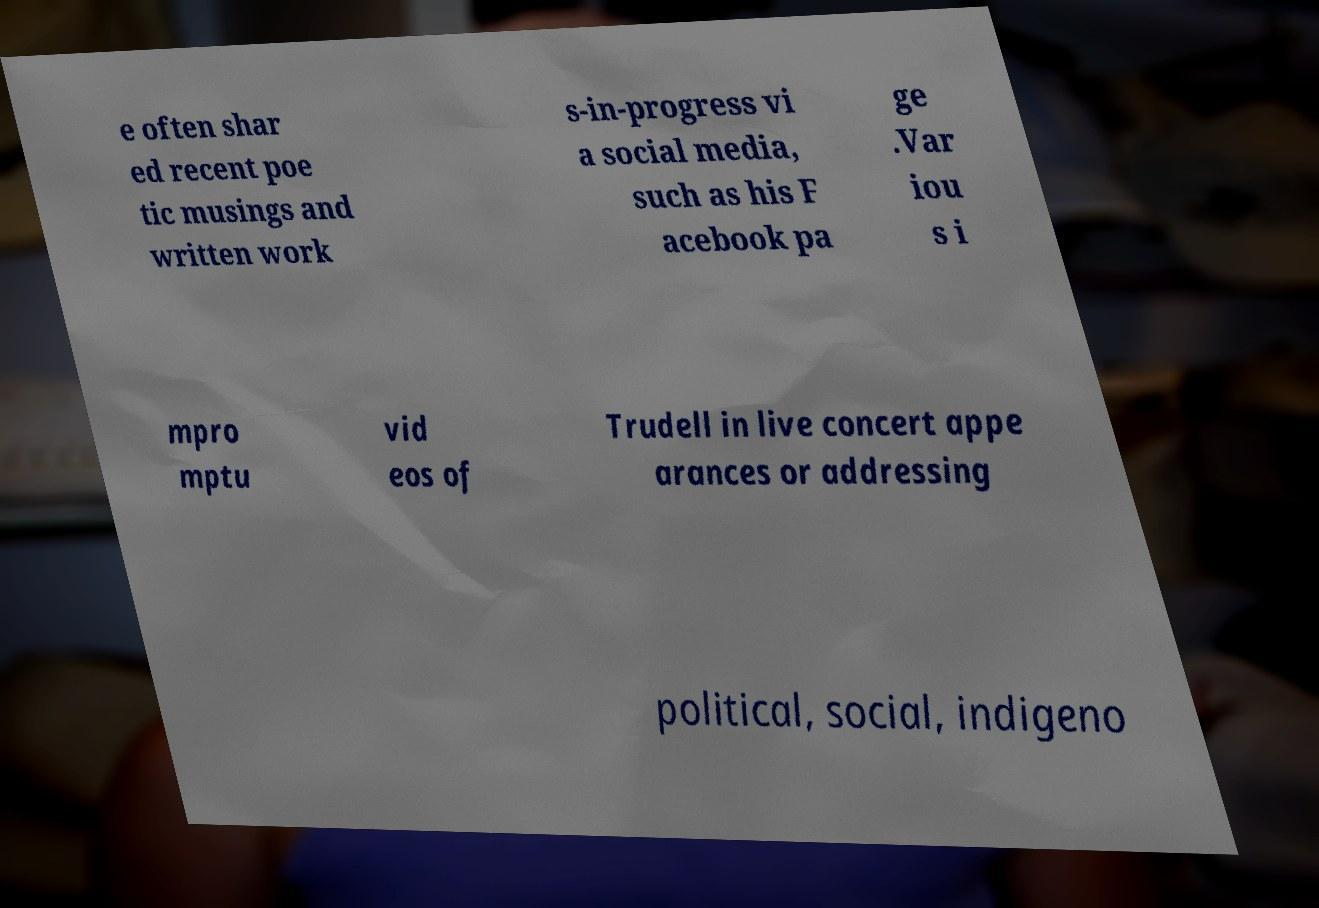For documentation purposes, I need the text within this image transcribed. Could you provide that? e often shar ed recent poe tic musings and written work s-in-progress vi a social media, such as his F acebook pa ge .Var iou s i mpro mptu vid eos of Trudell in live concert appe arances or addressing political, social, indigeno 